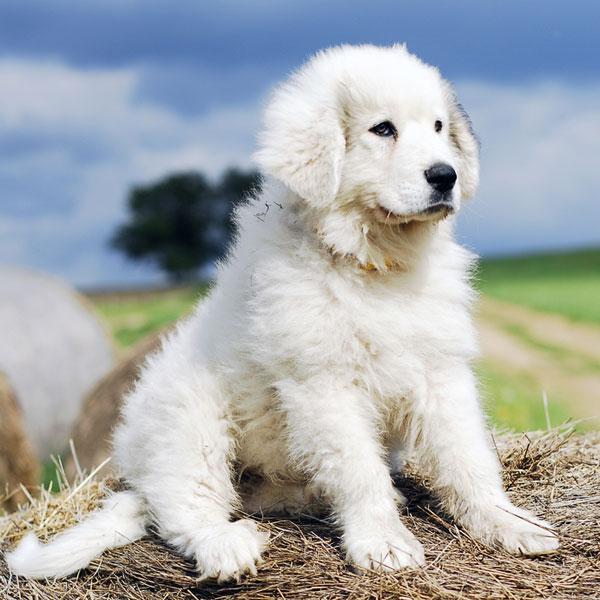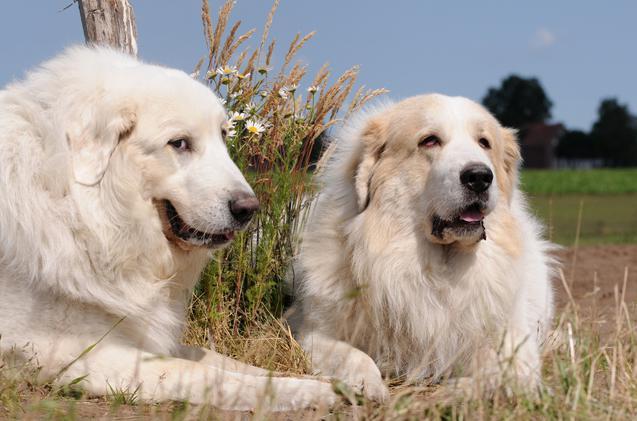The first image is the image on the left, the second image is the image on the right. Analyze the images presented: Is the assertion "the right image has mountains in the background" valid? Answer yes or no. No. The first image is the image on the left, the second image is the image on the right. Evaluate the accuracy of this statement regarding the images: "There is one dog facing right in the left image.". Is it true? Answer yes or no. Yes. 